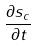Convert formula to latex. <formula><loc_0><loc_0><loc_500><loc_500>\frac { \partial s _ { c } } { \partial t }</formula> 